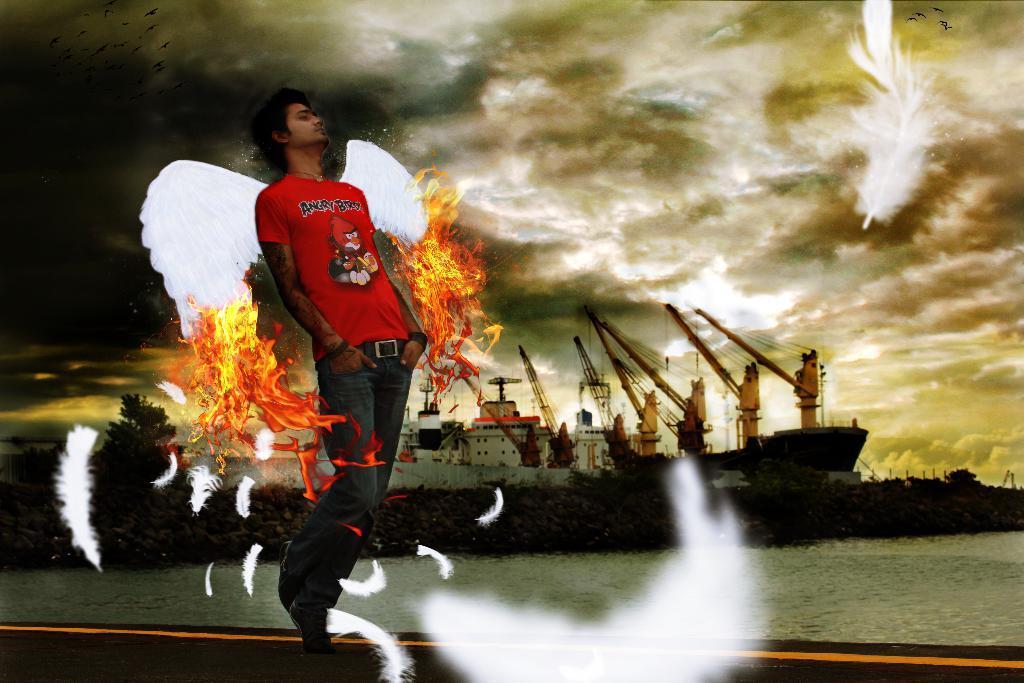In one or two sentences, can you explain what this image depicts? This is an edited picture. In this image there is a man with wings. At the back there are ships and cranes and there are trees. At the top there is sky and there are clouds. At the bottom there is water and there is a road and there are feathers in the air. 